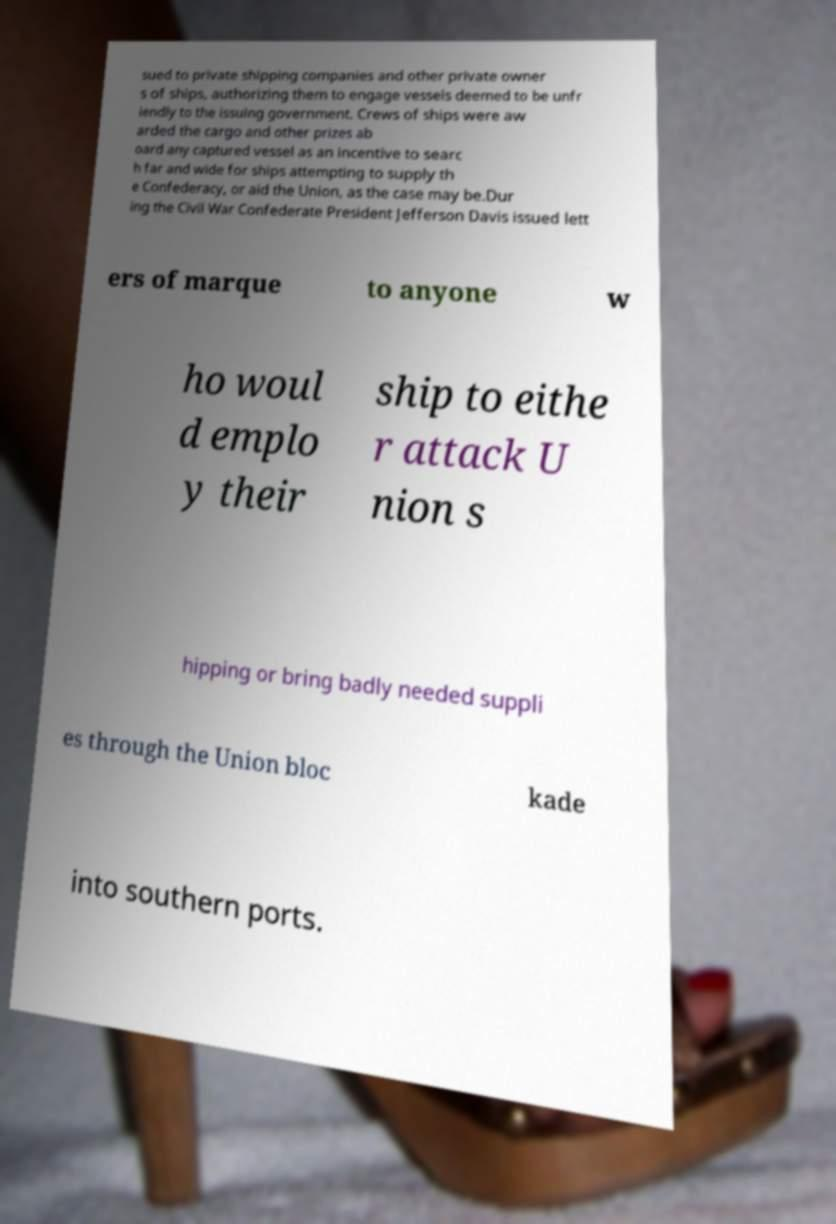There's text embedded in this image that I need extracted. Can you transcribe it verbatim? sued to private shipping companies and other private owner s of ships, authorizing them to engage vessels deemed to be unfr iendly to the issuing government. Crews of ships were aw arded the cargo and other prizes ab oard any captured vessel as an incentive to searc h far and wide for ships attempting to supply th e Confederacy, or aid the Union, as the case may be.Dur ing the Civil War Confederate President Jefferson Davis issued lett ers of marque to anyone w ho woul d emplo y their ship to eithe r attack U nion s hipping or bring badly needed suppli es through the Union bloc kade into southern ports. 